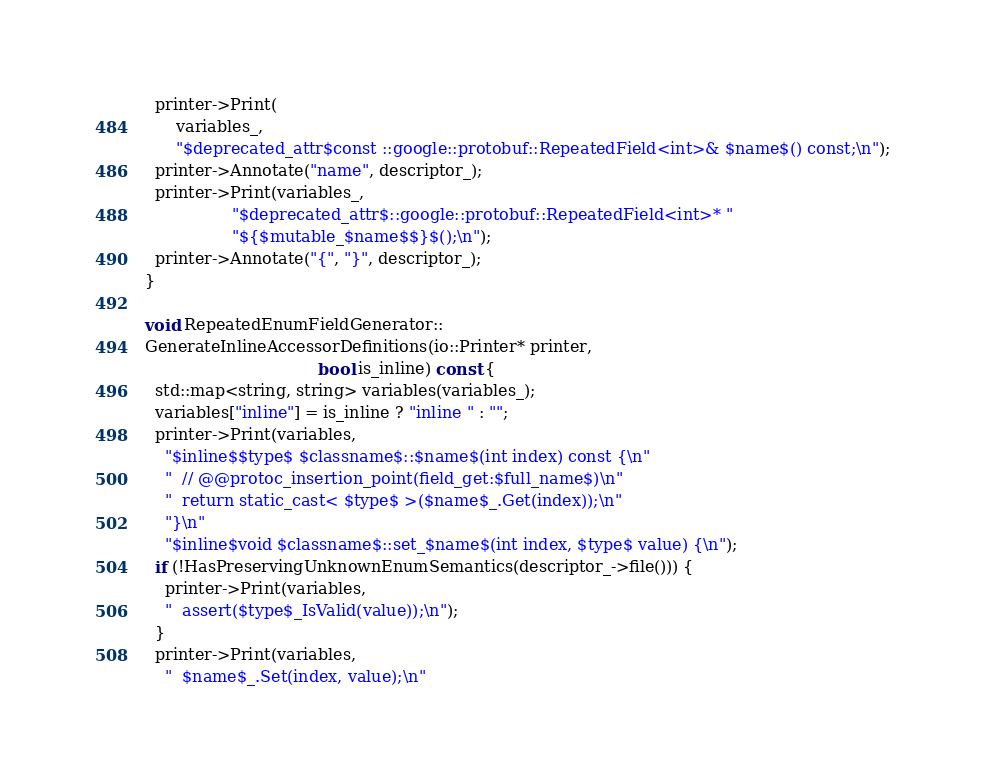<code> <loc_0><loc_0><loc_500><loc_500><_C++_>  printer->Print(
      variables_,
      "$deprecated_attr$const ::google::protobuf::RepeatedField<int>& $name$() const;\n");
  printer->Annotate("name", descriptor_);
  printer->Print(variables_,
                 "$deprecated_attr$::google::protobuf::RepeatedField<int>* "
                 "${$mutable_$name$$}$();\n");
  printer->Annotate("{", "}", descriptor_);
}

void RepeatedEnumFieldGenerator::
GenerateInlineAccessorDefinitions(io::Printer* printer,
                                  bool is_inline) const {
  std::map<string, string> variables(variables_);
  variables["inline"] = is_inline ? "inline " : "";
  printer->Print(variables,
    "$inline$$type$ $classname$::$name$(int index) const {\n"
    "  // @@protoc_insertion_point(field_get:$full_name$)\n"
    "  return static_cast< $type$ >($name$_.Get(index));\n"
    "}\n"
    "$inline$void $classname$::set_$name$(int index, $type$ value) {\n");
  if (!HasPreservingUnknownEnumSemantics(descriptor_->file())) {
    printer->Print(variables,
    "  assert($type$_IsValid(value));\n");
  }
  printer->Print(variables,
    "  $name$_.Set(index, value);\n"</code> 